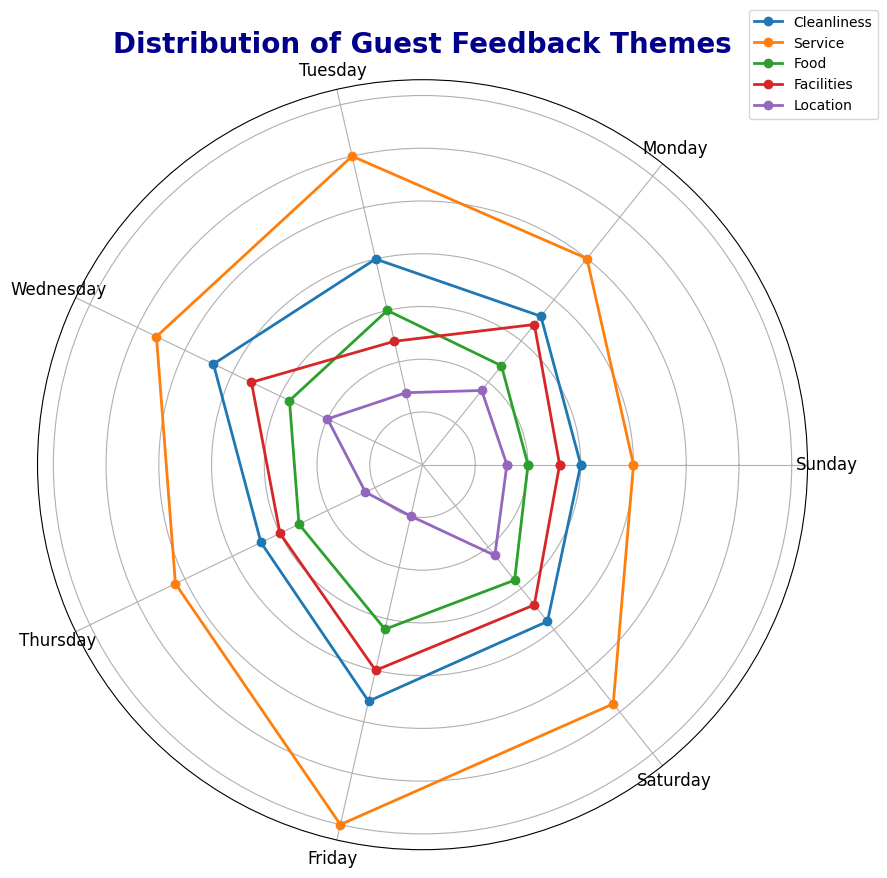Which theme has the highest feedback count on Friday? To determine which theme has the highest feedback count on Friday, look at the lengths of the lines extending from Friday. The longest line corresponds to "Service," with a count of 35.
Answer: Service How does the feedback for "Cleanliness" compare between Monday and Wednesday? To compare the feedback, examine the lengths of the "Cleanliness" lines on Monday and Wednesday. Monday shows a value of 18, while Wednesday shows a value of 22.
Answer: Cleanliness has higher feedback on Wednesday than Monday What is the total feedback count for the "Food" theme on weekends (Saturday and Sunday)? Add the counts for "Food" on Saturday and Sunday. Saturday has 14, and Sunday has 10. The sum is 14 + 10 = 24.
Answer: 24 On which day does the "Facilities" theme have the second-highest feedback count? Review all the "Facilities" theme counts for each day. The values are: Sunday (13), Monday (17), Tuesday (12), Wednesday (18), Thursday (15), Friday (20), and Saturday (17). The highest is Friday (20) and the second-highest is Wednesday (18).
Answer: Wednesday Is the "Location" feedback count ever higher on Sunday than on Friday? Compare the feedback counts for "Location" on Sunday and Friday. Sunday has a value of 8, and Friday shows 5. Therefore, Sunday’s feedback is higher.
Answer: Yes What's the average feedback count for the "Service" theme? To calculate the average, sum the "Service" theme counts for each day (20+25+30+28+26+35+29=193) and divide by the number of days (7). The average is 193/7 ≈ 27.57.
Answer: ≈ 27.57 How much more feedback does "Service" receive on Friday compared to Sunday? Subtract the "Service" feedback count on Sunday (20) from the count on Friday (35). The difference is 35 - 20 = 15.
Answer: 15 